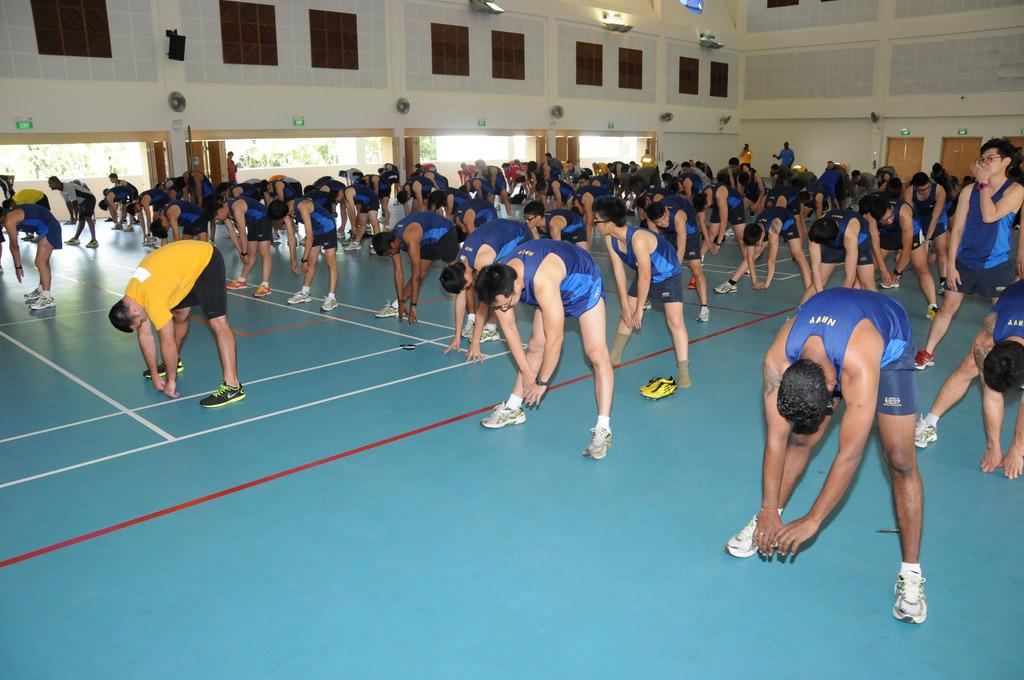How many people are in the image? There is a group of persons standing in the image, but the exact number cannot be determined from the provided facts. What can be seen in the background of the image? There are windows, doors, and a wall in the background of the image. What type of string is being used to hold up the cannon in the image? There is no cannon present in the image, so there is no string being used to hold it up. 